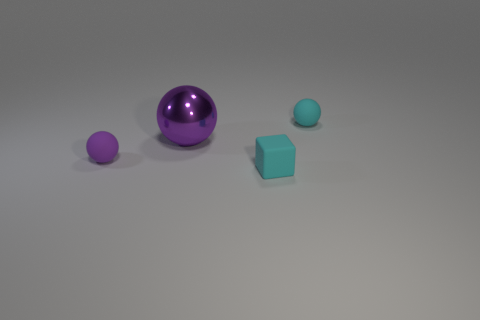There is a rubber object that is both behind the matte block and to the right of the shiny thing; what size is it?
Make the answer very short. Small. How many other objects are the same shape as the small purple matte thing?
Keep it short and to the point. 2. How many spheres are purple objects or large objects?
Your response must be concise. 2. Are there any cubes that are behind the small rubber ball on the right side of the small object that is left of the cyan block?
Provide a succinct answer. No. There is another small object that is the same shape as the tiny purple object; what is its color?
Offer a very short reply. Cyan. What number of red things are big matte things or big things?
Keep it short and to the point. 0. What material is the purple ball behind the small sphere to the left of the purple shiny object made of?
Your answer should be very brief. Metal. Is the shape of the big metal object the same as the small purple matte object?
Make the answer very short. Yes. There is another matte sphere that is the same size as the purple matte sphere; what is its color?
Offer a very short reply. Cyan. Are there any big metal spheres that have the same color as the large metal thing?
Offer a terse response. No. 